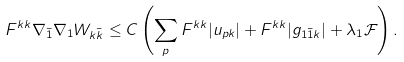Convert formula to latex. <formula><loc_0><loc_0><loc_500><loc_500>F ^ { k k } \nabla _ { \bar { 1 } } \nabla _ { 1 } W _ { k \bar { k } } & \leq C \left ( \sum _ { p } F ^ { k k } | u _ { p k } | + F ^ { k k } | g _ { 1 \bar { 1 } k } | + \lambda _ { 1 } \mathcal { F } \right ) .</formula> 